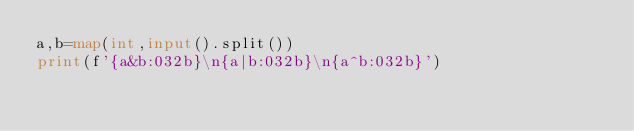Convert code to text. <code><loc_0><loc_0><loc_500><loc_500><_Python_>a,b=map(int,input().split())
print(f'{a&b:032b}\n{a|b:032b}\n{a^b:032b}')
</code> 